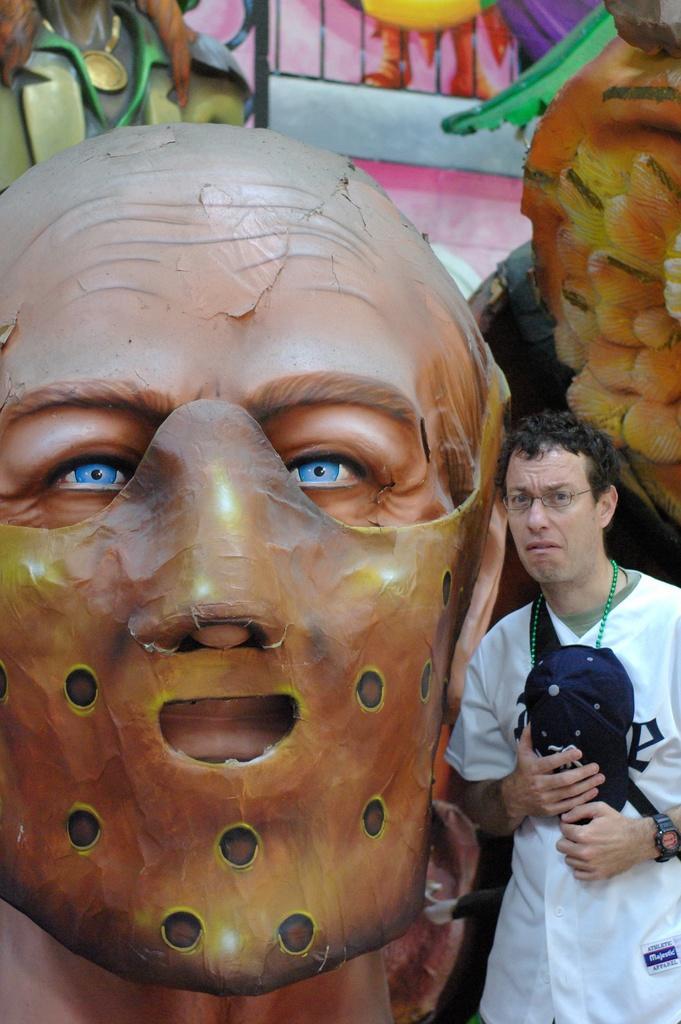How would you summarize this image in a sentence or two? In this image I can see a person standing beside the mask. The person is wearing white dress and black cap, and the wall is in multicolor. 